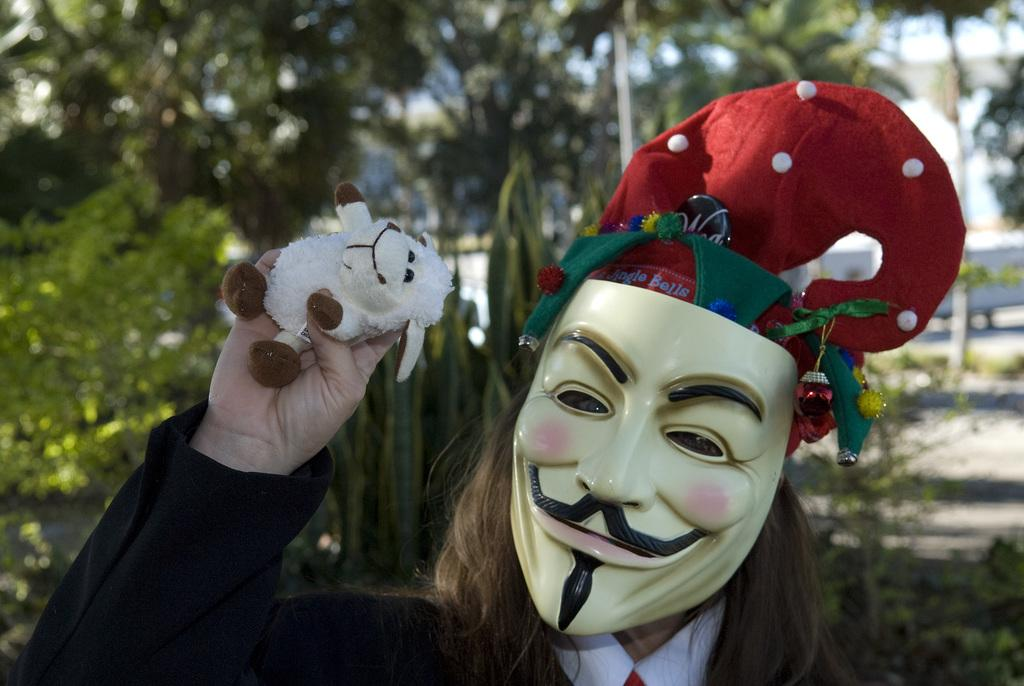Who is present in the image? There is a person in the image. What is the person wearing? The person is wearing a mask. What is the person holding? The person is holding a toy. What can be seen in the background of the image? There are trees in the background of the image. What type of base is the person using to sleep in the image? There is no base or sleeping activity present in the image; the person is standing and holding a toy. 